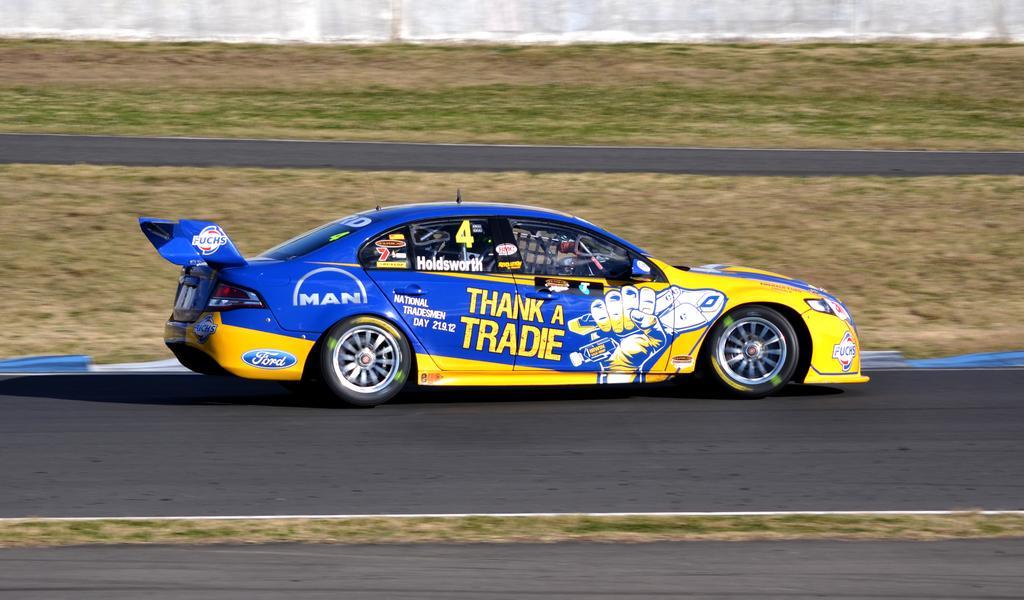Could you give a brief overview of what you see in this image? There is a sports car moving on a road it is of yellow and blue color and there are some paintings done on the car,behind the car there is a lot of grass and in between the grass there is a road. 